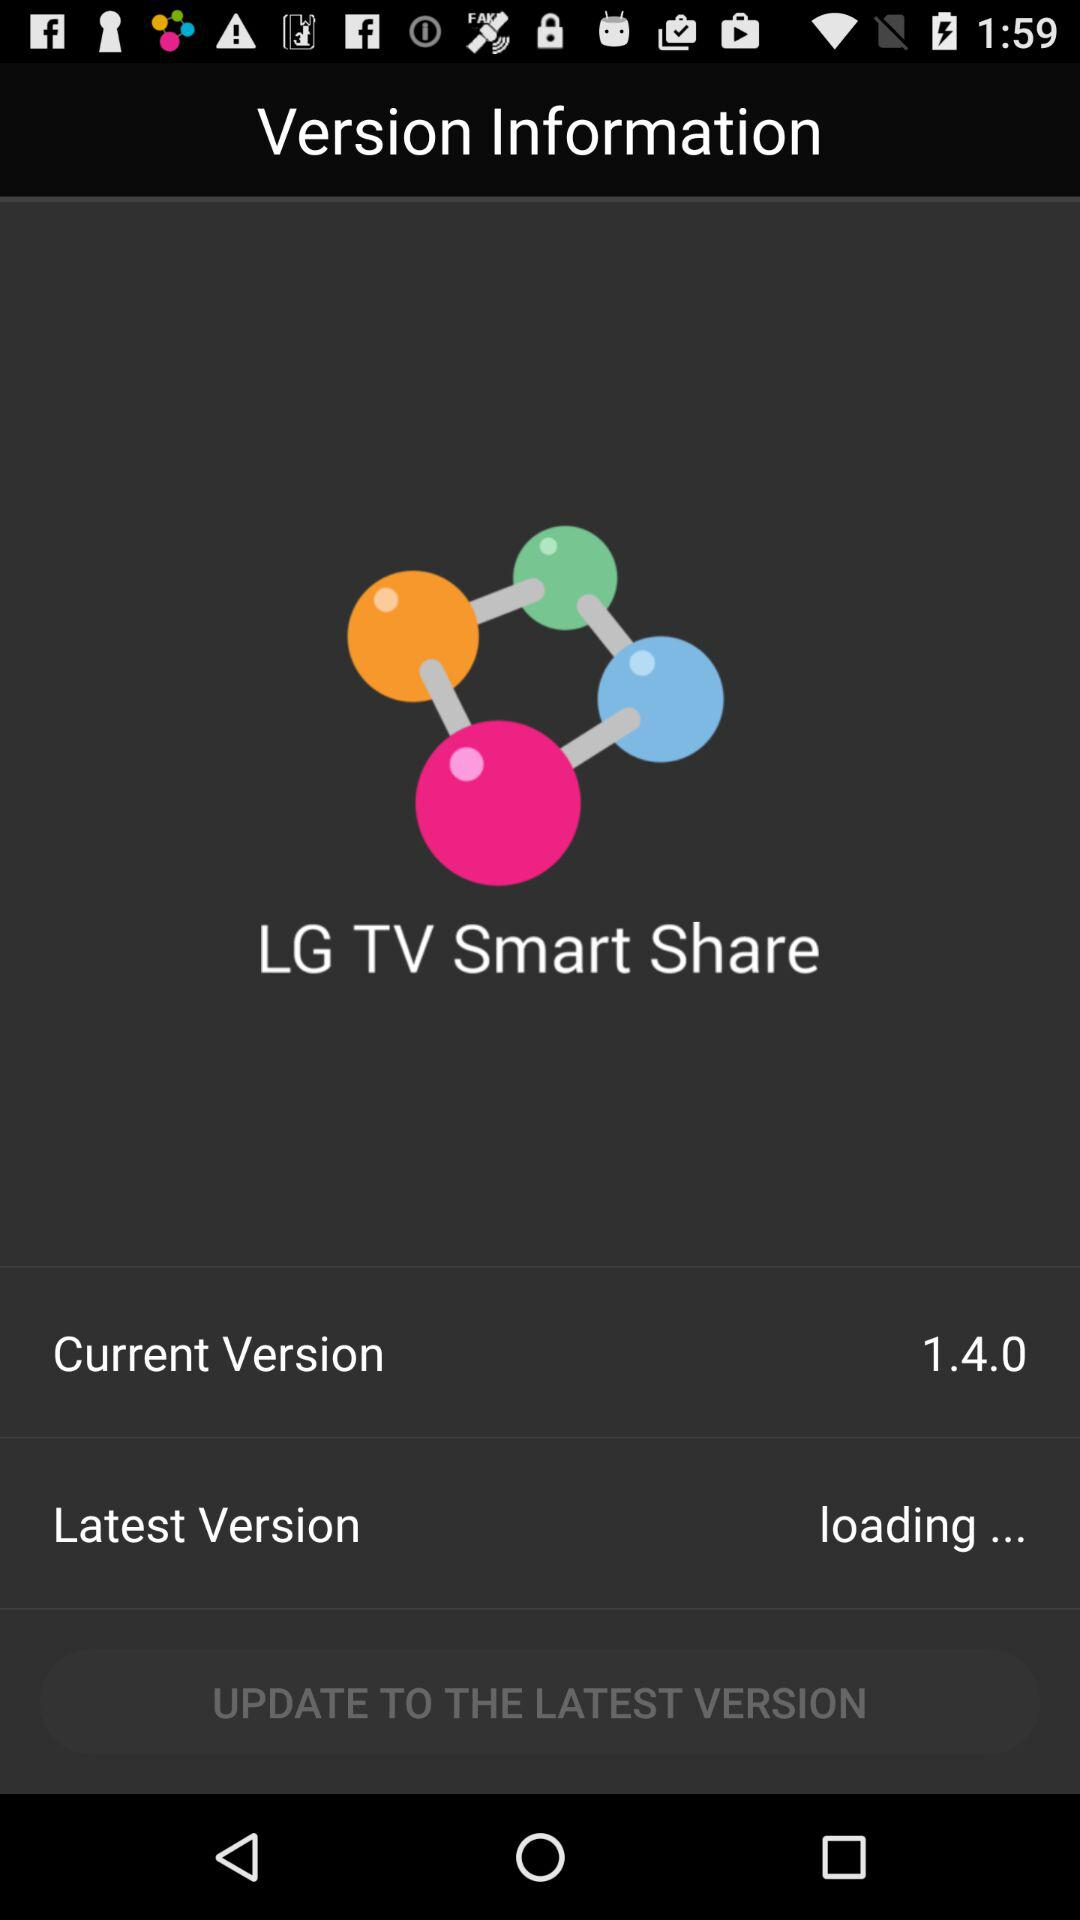What is the current version of the application? The current version of the application is 1.4.0. 